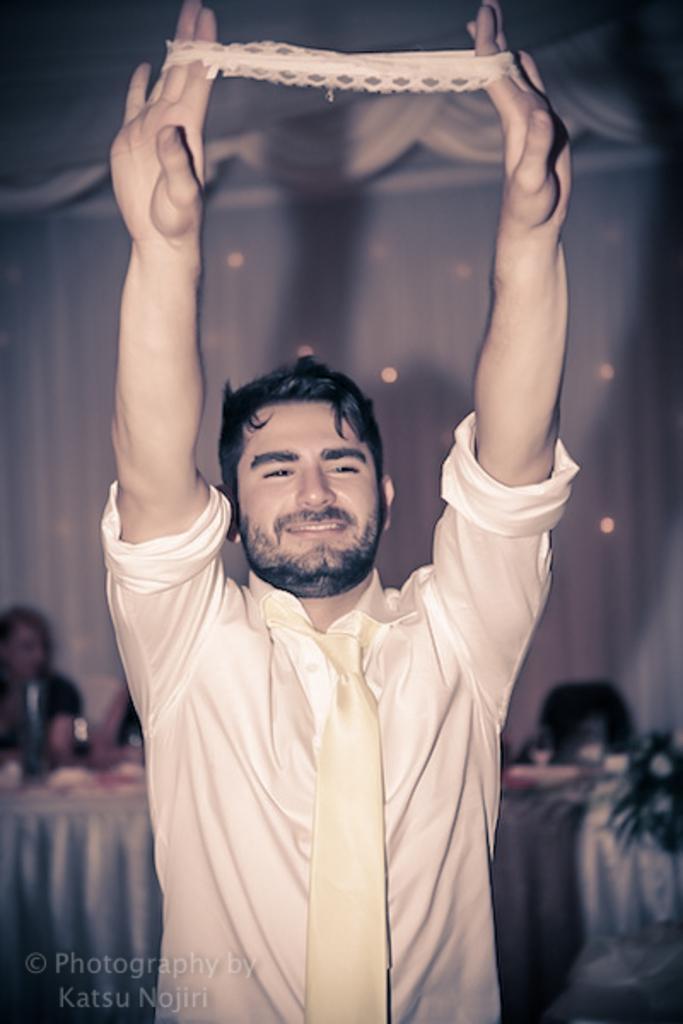Describe this image in one or two sentences. In this image we can see a man. He is wearing a shirt, tie and holding white color cloth like thing in his hand. In the background, we can see people, chair, flower pot and table. There is a watermark in the left bottom of the image. 